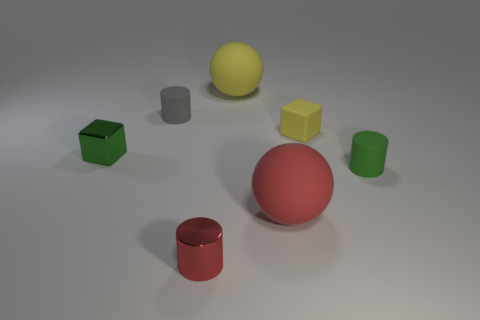Does the green thing to the left of the tiny gray object have the same size as the matte sphere on the right side of the yellow rubber ball?
Ensure brevity in your answer.  No. The small rubber cube has what color?
Offer a terse response. Yellow. Is the shape of the metallic thing in front of the small green shiny object the same as  the small yellow rubber thing?
Keep it short and to the point. No. What is the material of the large yellow ball?
Your response must be concise. Rubber. The thing that is the same size as the yellow sphere is what shape?
Keep it short and to the point. Sphere. Is there a tiny rubber block of the same color as the tiny shiny cylinder?
Your answer should be compact. No. Is the color of the matte block the same as the shiny thing to the right of the small gray thing?
Keep it short and to the point. No. What color is the shiny thing that is on the right side of the metallic thing that is on the left side of the tiny red metallic object?
Provide a short and direct response. Red. Is there a matte block that is behind the rubber cylinder to the left of the tiny shiny object that is right of the green cube?
Provide a succinct answer. No. The small thing that is the same material as the green cube is what color?
Ensure brevity in your answer.  Red. 